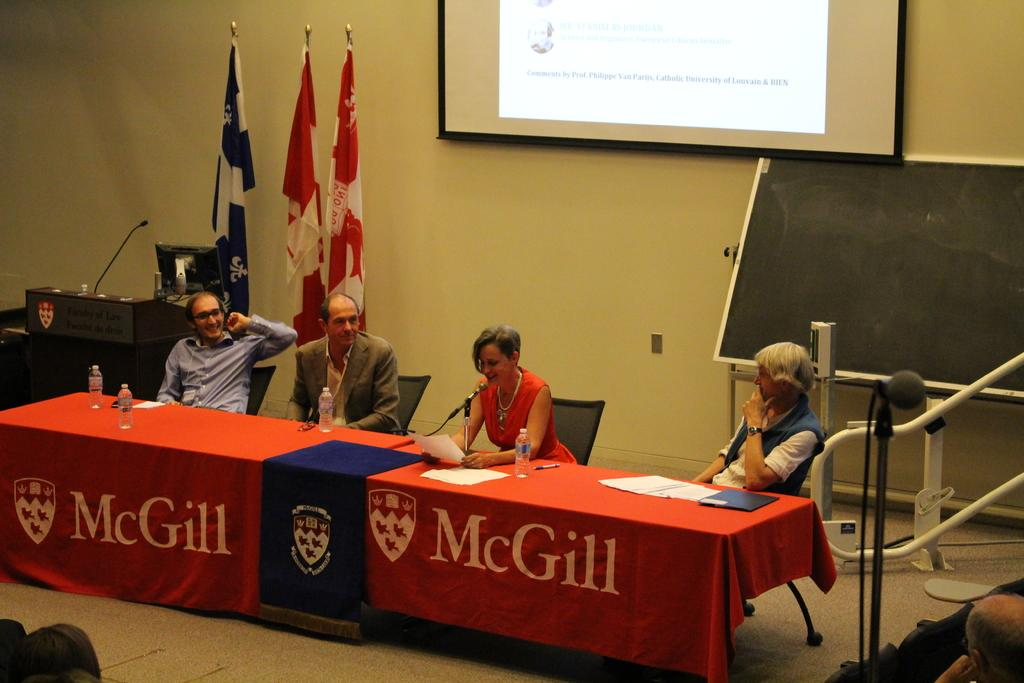How many people are sitting in the image? There are four persons sitting on chairs in the image. What is present on the table in the image? There are bottles, a paper, and pens on the table in the image. What can be seen in the background of the image? There is a wall, a screen, a board, and flags in the background of the image. What is the surface visible beneath the people and table? There is a floor visible in the image. Is the sister of one of the persons sitting in the image visible? There is no mention of a sister or any other family members in the image. Can you see a hill in the background of the image? There is no hill visible in the image; the background features a wall, a screen, a board, and flags. 